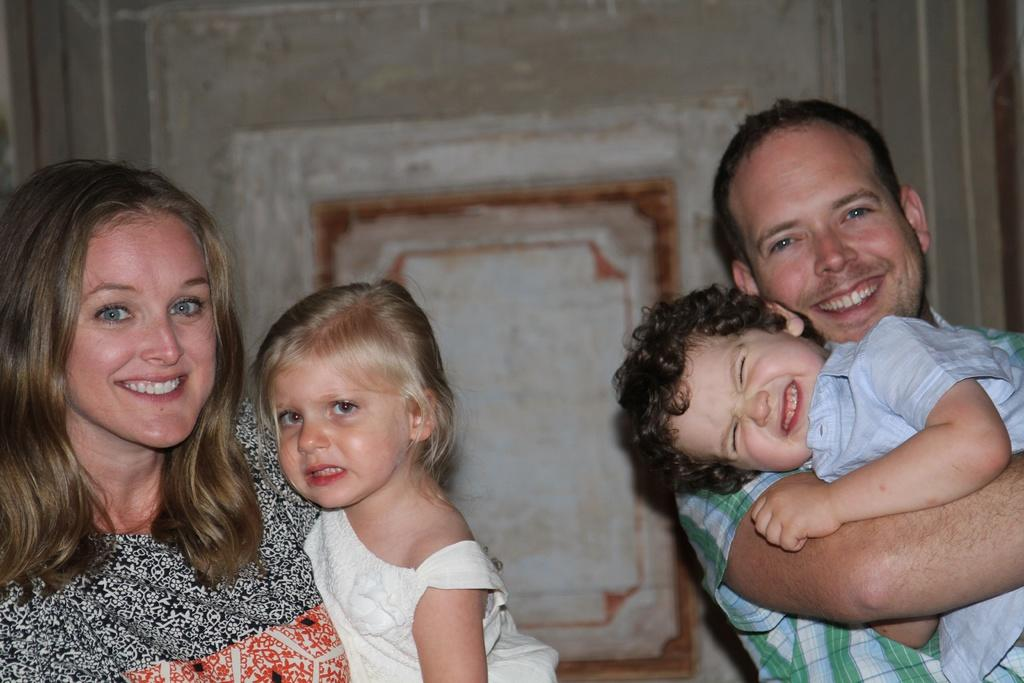How many people are present in the image? There are two people in the image, a man and a woman. What are the man and woman doing in the image? The man and woman are holding kids in the image. What can be seen in the background of the image? There is a wall in the background of the image. What type of sail can be seen in the image? There is no sail present in the image. How does the cannon affect the interaction between the man and woman in the image? There is no cannon present in the image, so it does not affect the interaction between the man and woman. 